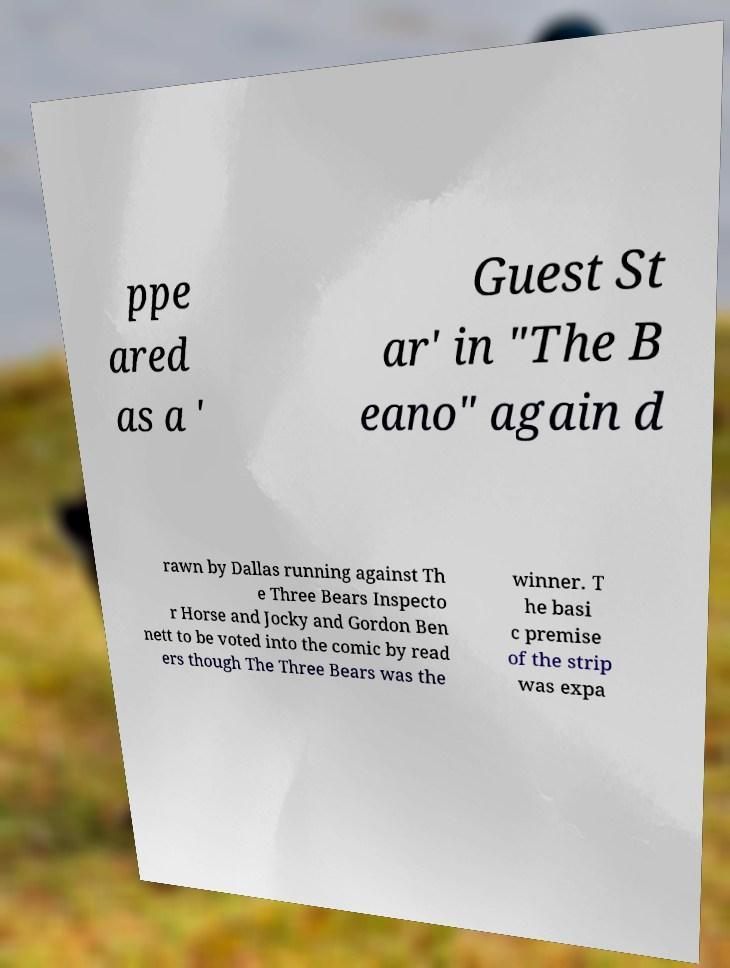Please identify and transcribe the text found in this image. ppe ared as a ' Guest St ar' in "The B eano" again d rawn by Dallas running against Th e Three Bears Inspecto r Horse and Jocky and Gordon Ben nett to be voted into the comic by read ers though The Three Bears was the winner. T he basi c premise of the strip was expa 